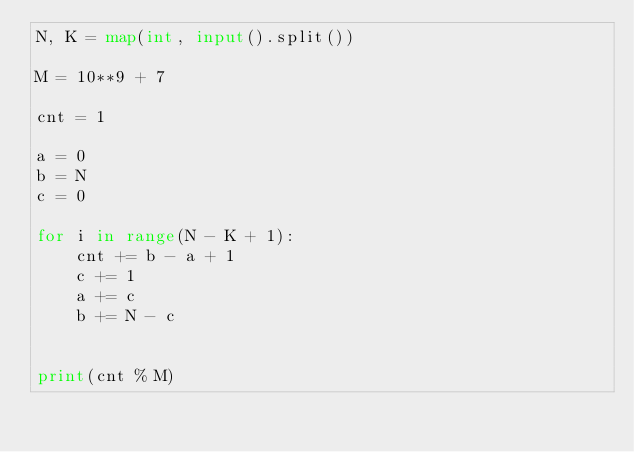Convert code to text. <code><loc_0><loc_0><loc_500><loc_500><_Python_>N, K = map(int, input().split())

M = 10**9 + 7

cnt = 1

a = 0
b = N
c = 0

for i in range(N - K + 1):
    cnt += b - a + 1
    c += 1
    a += c
    b += N - c


print(cnt % M)
</code> 